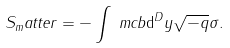Convert formula to latex. <formula><loc_0><loc_0><loc_500><loc_500>S _ { m } a t t e r = - \int _ { \ } m c b \mathrm d ^ { D } y \sqrt { - q } \sigma .</formula> 